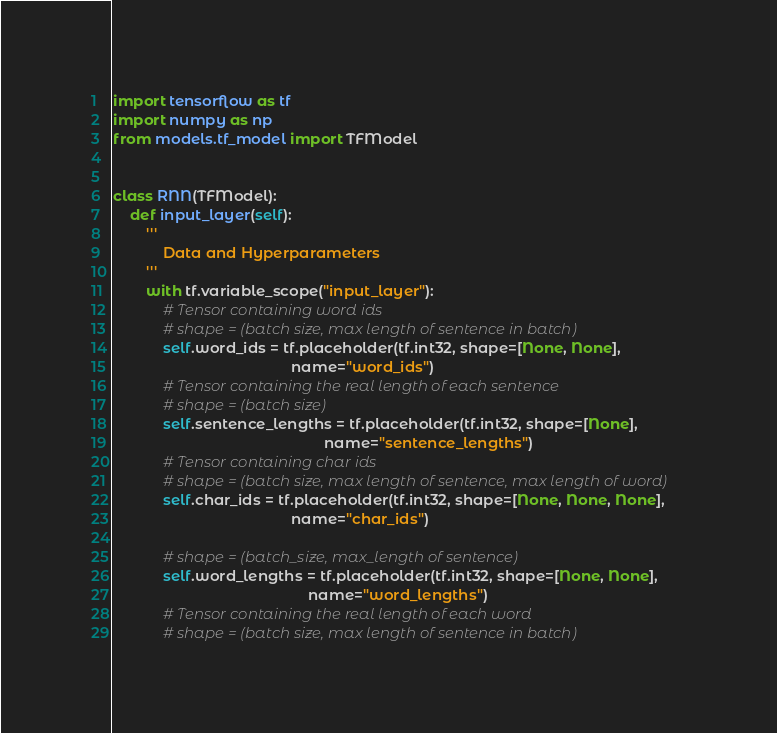<code> <loc_0><loc_0><loc_500><loc_500><_Python_>import tensorflow as tf
import numpy as np
from models.tf_model import TFModel


class RNN(TFModel):
    def input_layer(self):
        '''
            Data and Hyperparameters
        '''
        with tf.variable_scope("input_layer"):
            # Tensor containing word ids
            # shape = (batch size, max length of sentence in batch)
            self.word_ids = tf.placeholder(tf.int32, shape=[None, None],
                                           name="word_ids")
            # Tensor containing the real length of each sentence
            # shape = (batch size)
            self.sentence_lengths = tf.placeholder(tf.int32, shape=[None],
                                                   name="sentence_lengths")
            # Tensor containing char ids
            # shape = (batch size, max length of sentence, max length of word)
            self.char_ids = tf.placeholder(tf.int32, shape=[None, None, None],
                                           name="char_ids")

            # shape = (batch_size, max_length of sentence)
            self.word_lengths = tf.placeholder(tf.int32, shape=[None, None],
                                               name="word_lengths")
            # Tensor containing the real length of each word
            # shape = (batch size, max length of sentence in batch)</code> 